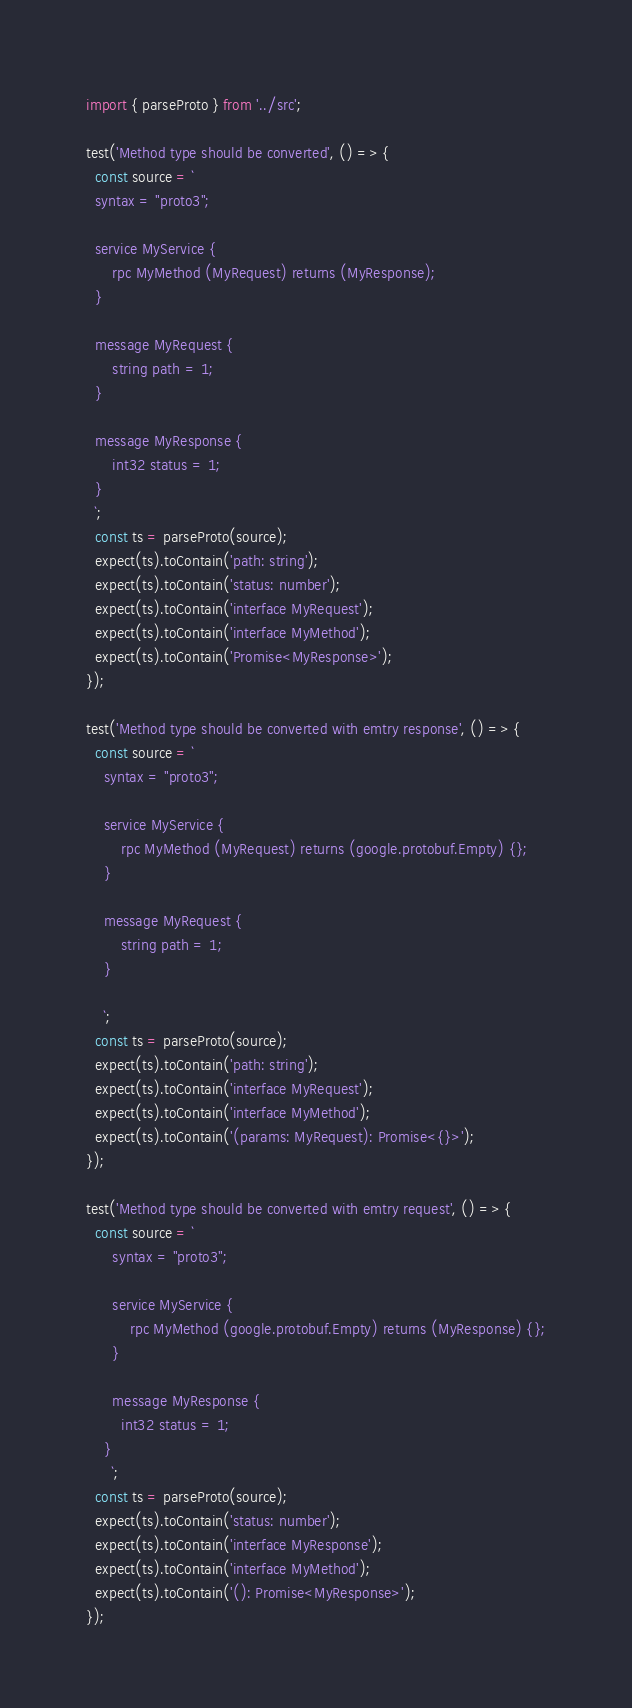Convert code to text. <code><loc_0><loc_0><loc_500><loc_500><_TypeScript_>import { parseProto } from '../src';

test('Method type should be converted', () => {
  const source = `
  syntax = "proto3";

  service MyService {
      rpc MyMethod (MyRequest) returns (MyResponse);
  }
  
  message MyRequest {
      string path = 1;
  }
  
  message MyResponse {
      int32 status = 1;
  }
  `;
  const ts = parseProto(source);
  expect(ts).toContain('path: string');
  expect(ts).toContain('status: number');
  expect(ts).toContain('interface MyRequest');
  expect(ts).toContain('interface MyMethod');
  expect(ts).toContain('Promise<MyResponse>');
});

test('Method type should be converted with emtry response', () => {
  const source = `
    syntax = "proto3";
  
    service MyService {
        rpc MyMethod (MyRequest) returns (google.protobuf.Empty) {};
    }
    
    message MyRequest {
        string path = 1;
    }
    
    `;
  const ts = parseProto(source);
  expect(ts).toContain('path: string');
  expect(ts).toContain('interface MyRequest');
  expect(ts).toContain('interface MyMethod');
  expect(ts).toContain('(params: MyRequest): Promise<{}>');
});

test('Method type should be converted with emtry request', () => {
  const source = `
      syntax = "proto3";
    
      service MyService {
          rpc MyMethod (google.protobuf.Empty) returns (MyResponse) {};
      }
      
      message MyResponse {
        int32 status = 1;
    }
      `;
  const ts = parseProto(source);
  expect(ts).toContain('status: number');
  expect(ts).toContain('interface MyResponse');
  expect(ts).toContain('interface MyMethod');
  expect(ts).toContain('(): Promise<MyResponse>');
});
</code> 